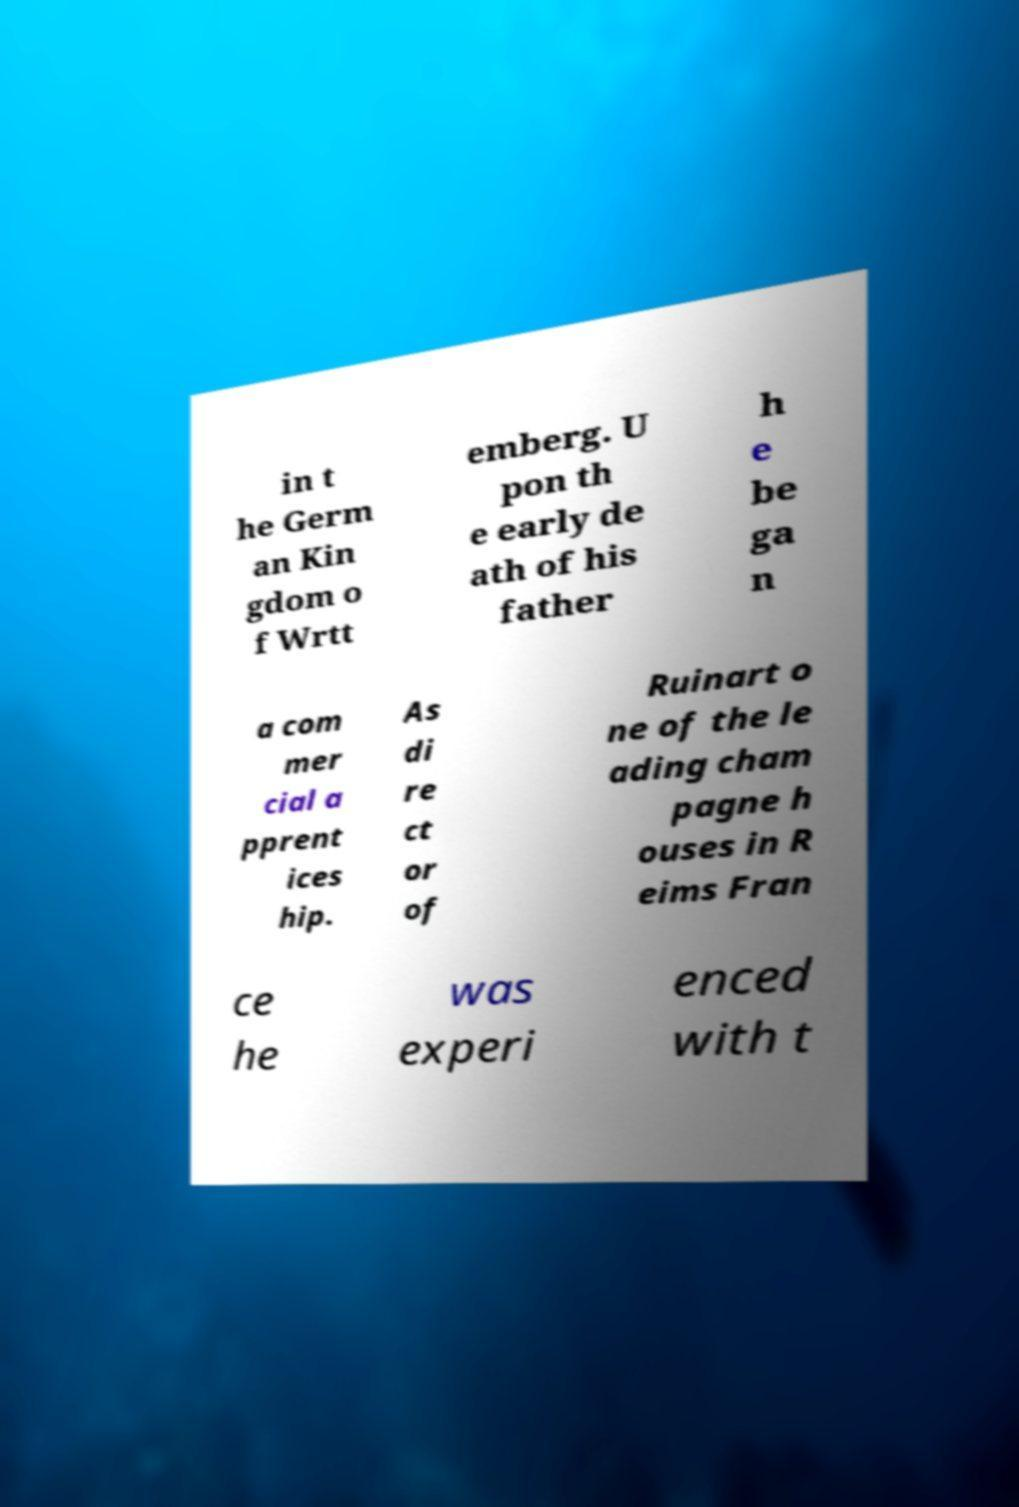For documentation purposes, I need the text within this image transcribed. Could you provide that? in t he Germ an Kin gdom o f Wrtt emberg. U pon th e early de ath of his father h e be ga n a com mer cial a pprent ices hip. As di re ct or of Ruinart o ne of the le ading cham pagne h ouses in R eims Fran ce he was experi enced with t 